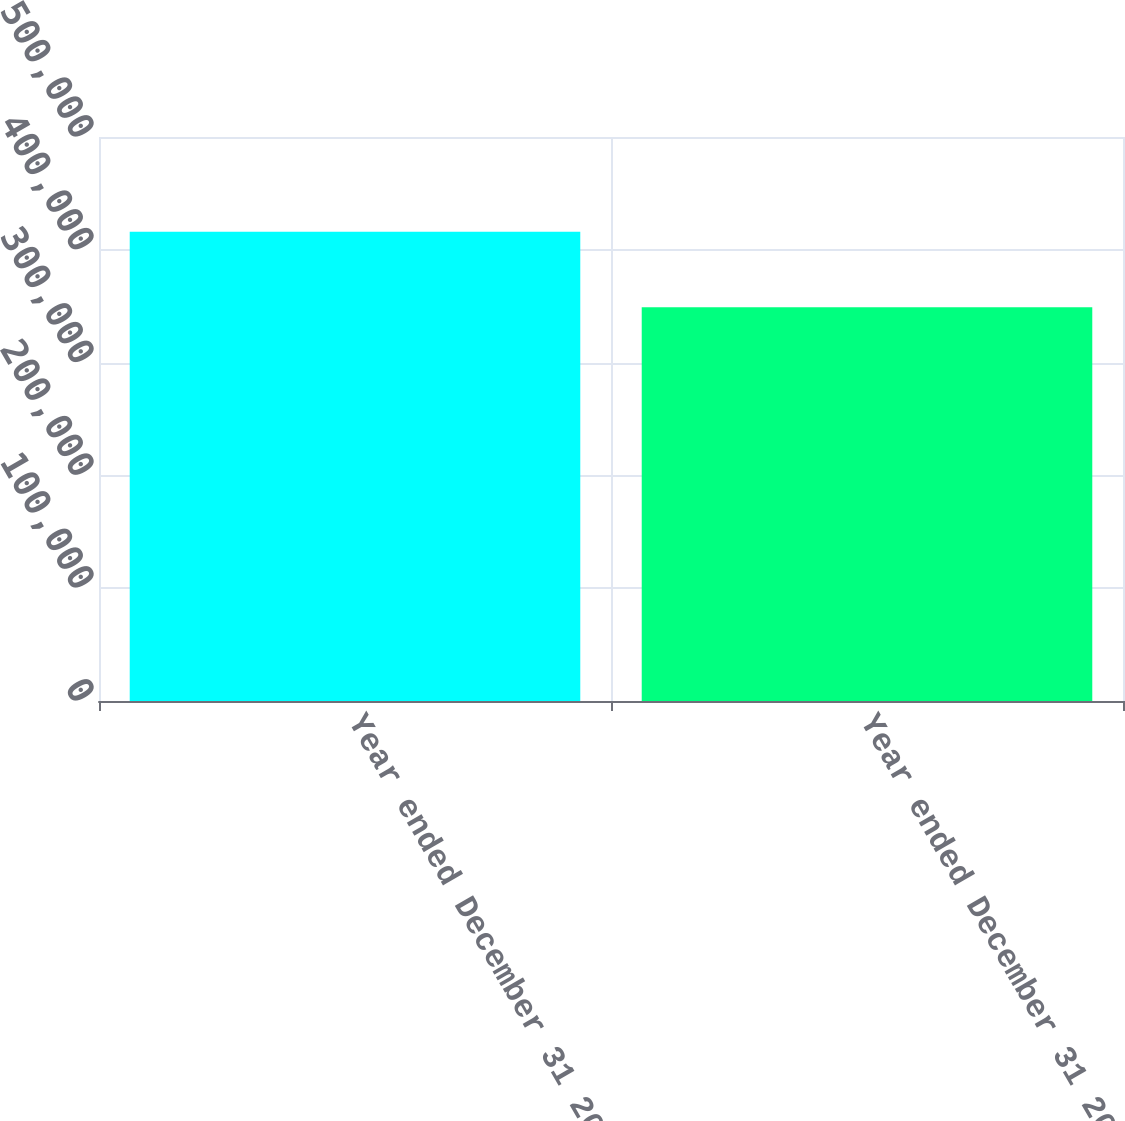<chart> <loc_0><loc_0><loc_500><loc_500><bar_chart><fcel>Year ended December 31 2007<fcel>Year ended December 31 2006<nl><fcel>415961<fcel>349030<nl></chart> 